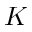<formula> <loc_0><loc_0><loc_500><loc_500>K</formula> 